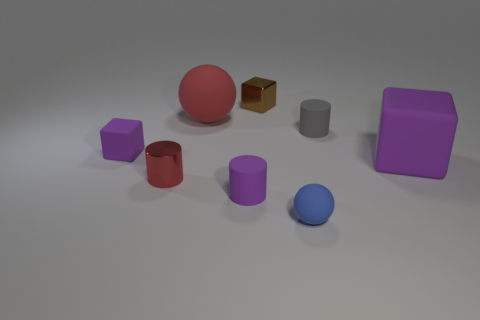How many purple cubes must be subtracted to get 1 purple cubes? 1 Subtract 1 cylinders. How many cylinders are left? 2 Add 2 large gray cylinders. How many objects exist? 10 Subtract all blocks. How many objects are left? 5 Subtract 1 purple cubes. How many objects are left? 7 Subtract all purple metallic cylinders. Subtract all blue rubber balls. How many objects are left? 7 Add 5 small purple blocks. How many small purple blocks are left? 6 Add 5 tiny rubber spheres. How many tiny rubber spheres exist? 6 